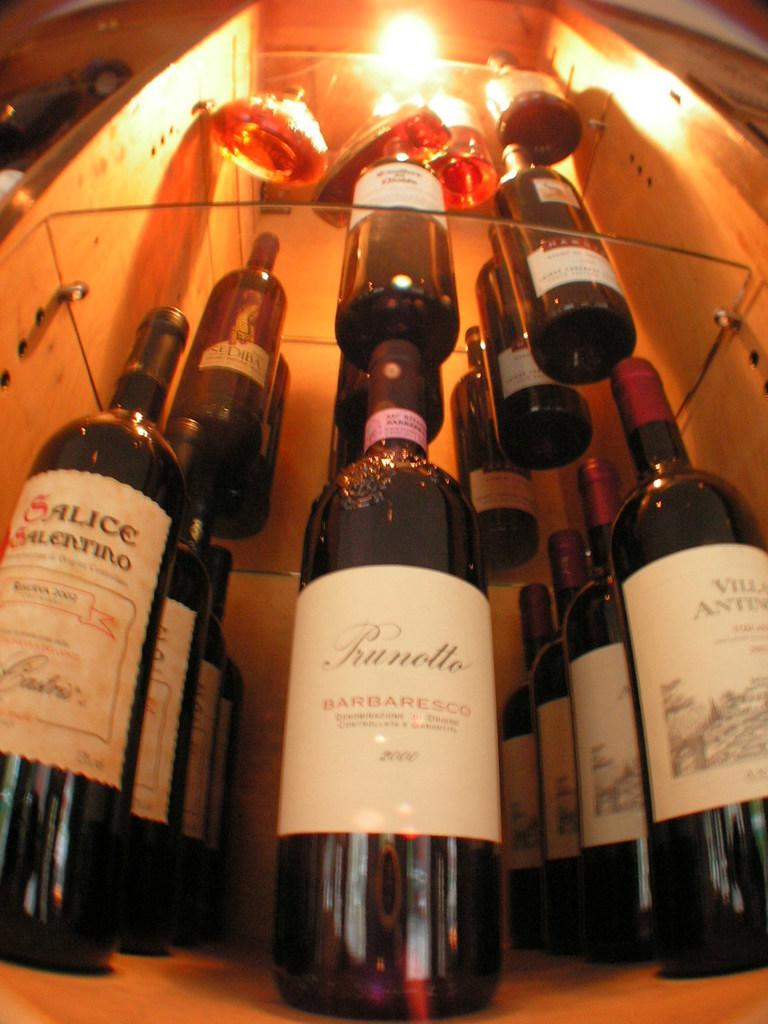What is the main object visible in the image? There is a wine bottle in the image. Where is the wine bottle located? The wine bottle is arranged in a shelf. What can be seen in the background of the image? There is a light visible in the background of the image. What type of note is attached to the wine bottle in the image? There is no note attached to the wine bottle in the image. Is anyone attempting to open the wine bottle in the image? There is no indication in the image of anyone attempting to open the wine bottle. What type of hat is visible on the shelf next to the wine bottle? There is no hat visible on the shelf next to the wine bottle in the image. 